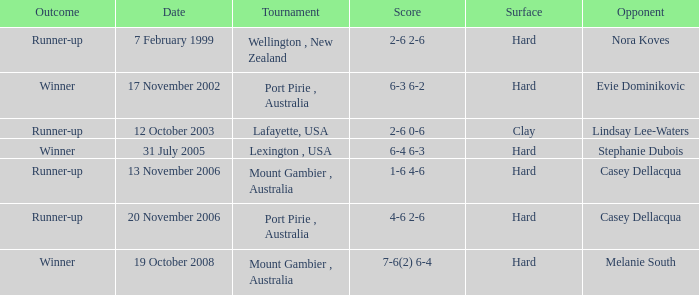Parse the full table. {'header': ['Outcome', 'Date', 'Tournament', 'Score', 'Surface', 'Opponent'], 'rows': [['Runner-up', '7 February 1999', 'Wellington , New Zealand', '2-6 2-6', 'Hard', 'Nora Koves'], ['Winner', '17 November 2002', 'Port Pirie , Australia', '6-3 6-2', 'Hard', 'Evie Dominikovic'], ['Runner-up', '12 October 2003', 'Lafayette, USA', '2-6 0-6', 'Clay', 'Lindsay Lee-Waters'], ['Winner', '31 July 2005', 'Lexington , USA', '6-4 6-3', 'Hard', 'Stephanie Dubois'], ['Runner-up', '13 November 2006', 'Mount Gambier , Australia', '1-6 4-6', 'Hard', 'Casey Dellacqua'], ['Runner-up', '20 November 2006', 'Port Pirie , Australia', '4-6 2-6', 'Hard', 'Casey Dellacqua'], ['Winner', '19 October 2008', 'Mount Gambier , Australia', '7-6(2) 6-4', 'Hard', 'Melanie South']]} Which is the Outcome on 13 november 2006? Runner-up. 